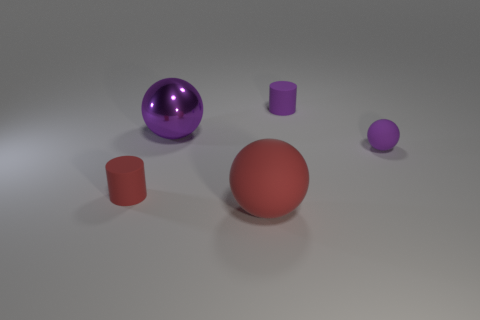The sphere that is left of the rubber sphere to the left of the small cylinder behind the red cylinder is what color?
Keep it short and to the point. Purple. There is a large matte ball; is its color the same as the tiny matte cylinder to the left of the red ball?
Provide a succinct answer. Yes. What color is the large matte thing?
Ensure brevity in your answer.  Red. The tiny thing behind the purple thing on the right side of the object behind the purple metal ball is what shape?
Offer a very short reply. Cylinder. How many other things are there of the same color as the small sphere?
Provide a short and direct response. 2. Are there more objects on the left side of the large purple object than small purple cylinders that are to the left of the red rubber cylinder?
Give a very brief answer. Yes. Are there any large red things behind the large purple metal thing?
Your response must be concise. No. There is a tiny thing that is in front of the purple rubber cylinder and on the right side of the big red matte sphere; what is its material?
Provide a short and direct response. Rubber. What is the color of the other big object that is the same shape as the large rubber thing?
Keep it short and to the point. Purple. There is a big matte thing that is on the left side of the tiny purple ball; is there a large sphere that is on the left side of it?
Ensure brevity in your answer.  Yes. 